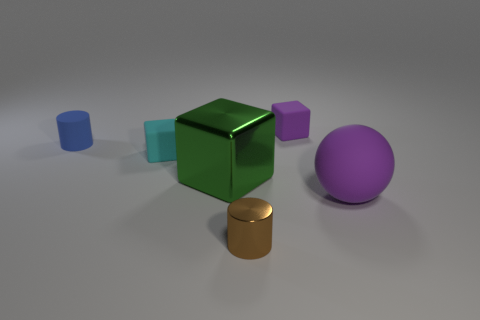Subtract all cyan cylinders. Subtract all purple spheres. How many cylinders are left? 2 Add 3 green shiny cubes. How many objects exist? 9 Subtract all balls. How many objects are left? 5 Add 4 blue things. How many blue things exist? 5 Subtract 0 blue spheres. How many objects are left? 6 Subtract all tiny cyan matte things. Subtract all small cyan matte objects. How many objects are left? 4 Add 5 small rubber cylinders. How many small rubber cylinders are left? 6 